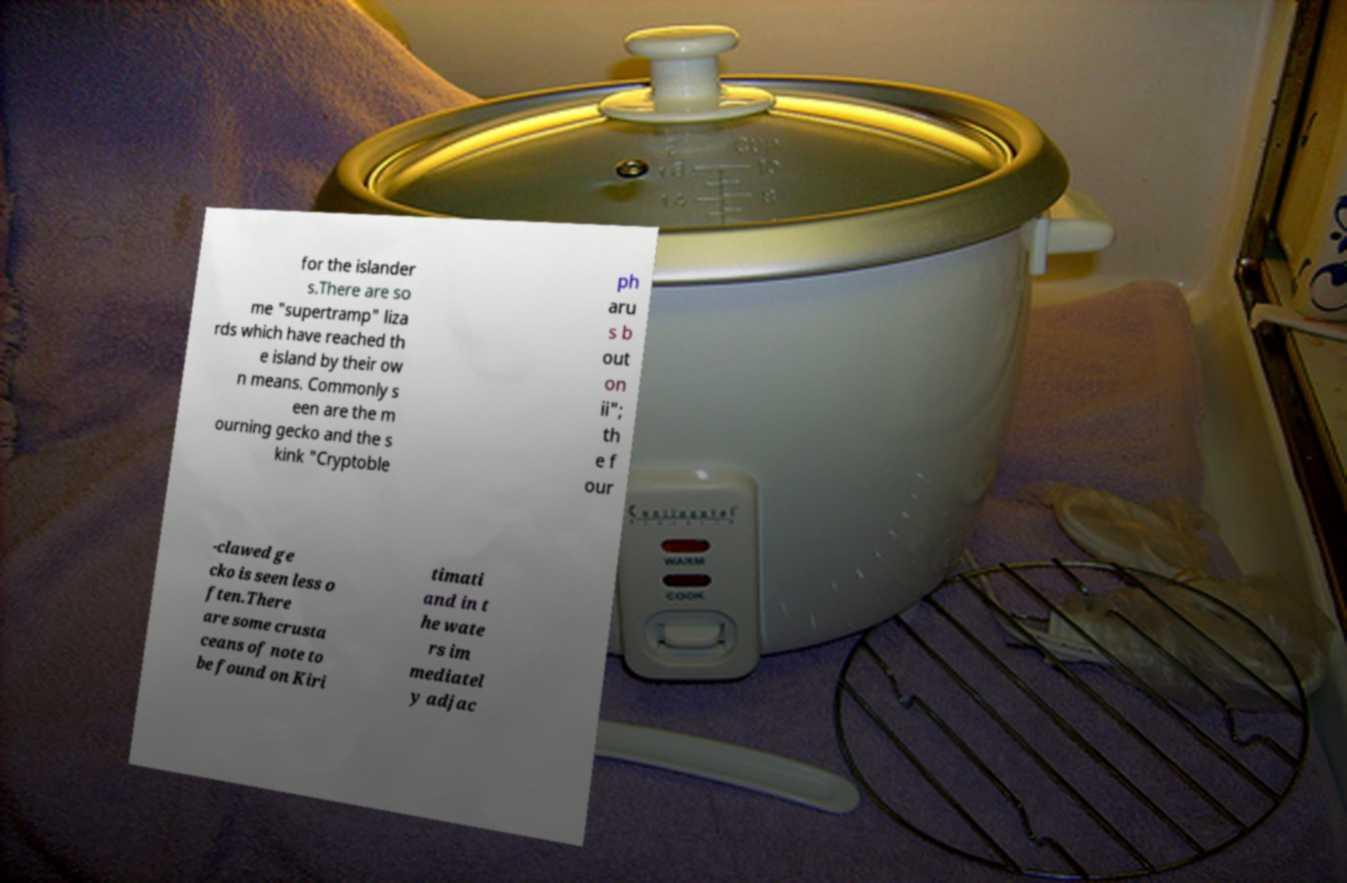For documentation purposes, I need the text within this image transcribed. Could you provide that? for the islander s.There are so me "supertramp" liza rds which have reached th e island by their ow n means. Commonly s een are the m ourning gecko and the s kink "Cryptoble ph aru s b out on ii"; th e f our -clawed ge cko is seen less o ften.There are some crusta ceans of note to be found on Kiri timati and in t he wate rs im mediatel y adjac 